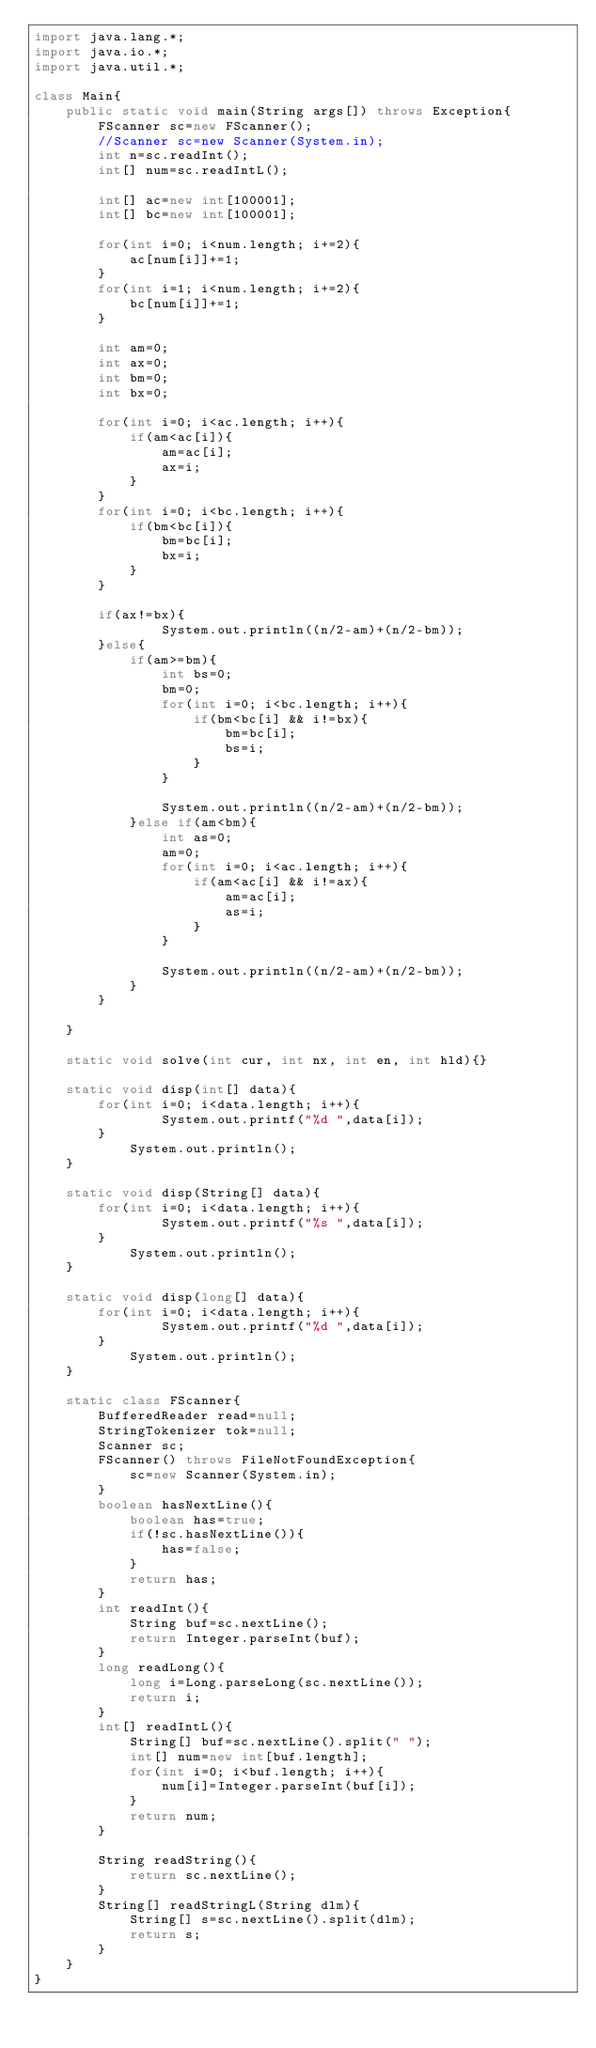<code> <loc_0><loc_0><loc_500><loc_500><_Java_>import java.lang.*;
import java.io.*;
import java.util.*;

class Main{
	public static void main(String args[]) throws Exception{
		FScanner sc=new FScanner();
		//Scanner sc=new Scanner(System.in);
		int n=sc.readInt();
		int[] num=sc.readIntL();
		
		int[] ac=new int[100001];
		int[] bc=new int[100001];
		
		for(int i=0; i<num.length; i+=2){
			ac[num[i]]+=1;
		}
		for(int i=1; i<num.length; i+=2){
			bc[num[i]]+=1;
		}
		
		int am=0;
		int ax=0;
		int bm=0;
		int bx=0;
		
		for(int i=0; i<ac.length; i++){
			if(am<ac[i]){
				am=ac[i];
				ax=i;
			}
		}
		for(int i=0; i<bc.length; i++){
			if(bm<bc[i]){
				bm=bc[i];
				bx=i;
			}
		}
		
		if(ax!=bx){
				System.out.println((n/2-am)+(n/2-bm));
		}else{
			if(am>=bm){
				int bs=0;
				bm=0;
				for(int i=0; i<bc.length; i++){
					if(bm<bc[i] && i!=bx){
						bm=bc[i];
						bs=i;
					}
				}
				
				System.out.println((n/2-am)+(n/2-bm));
			}else if(am<bm){
				int as=0;
				am=0;
				for(int i=0; i<ac.length; i++){
					if(am<ac[i] && i!=ax){
						am=ac[i];
						as=i;
					}
				}
				
				System.out.println((n/2-am)+(n/2-bm));
			}
		}
		
	}
	
	static void solve(int cur, int nx, int en, int hld){}

	static void disp(int[] data){
		for(int i=0; i<data.length; i++){
				System.out.printf("%d ",data[i]);
		}
			System.out.println();
	}
	
	static void disp(String[] data){
		for(int i=0; i<data.length; i++){
				System.out.printf("%s ",data[i]);
		}
			System.out.println();
	}
	
	static void disp(long[] data){
		for(int i=0; i<data.length; i++){
				System.out.printf("%d ",data[i]);
		}
			System.out.println();
	}
	
	static class FScanner{
		BufferedReader read=null;
		StringTokenizer tok=null;
		Scanner sc;
		FScanner() throws FileNotFoundException{
			sc=new Scanner(System.in);
		}
		boolean hasNextLine(){
			boolean has=true;
			if(!sc.hasNextLine()){
				has=false;
			}
			return has;
		}
		int readInt(){
			String buf=sc.nextLine();
			return Integer.parseInt(buf);
		}
		long readLong(){
			long i=Long.parseLong(sc.nextLine());
			return i;
		}
		int[] readIntL(){
			String[] buf=sc.nextLine().split(" ");
			int[] num=new int[buf.length];
			for(int i=0; i<buf.length; i++){
				num[i]=Integer.parseInt(buf[i]);
			}
			return num;
		}
		
		String readString(){
			return sc.nextLine();
		}
		String[] readStringL(String dlm){
			String[] s=sc.nextLine().split(dlm);
			return s;
		}
	}
}
</code> 